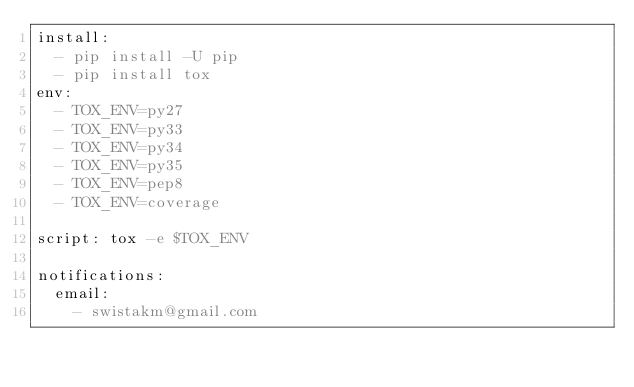<code> <loc_0><loc_0><loc_500><loc_500><_YAML_>install:
  - pip install -U pip
  - pip install tox
env:
  - TOX_ENV=py27
  - TOX_ENV=py33
  - TOX_ENV=py34
  - TOX_ENV=py35
  - TOX_ENV=pep8
  - TOX_ENV=coverage

script: tox -e $TOX_ENV

notifications:
  email:
    - swistakm@gmail.com
</code> 